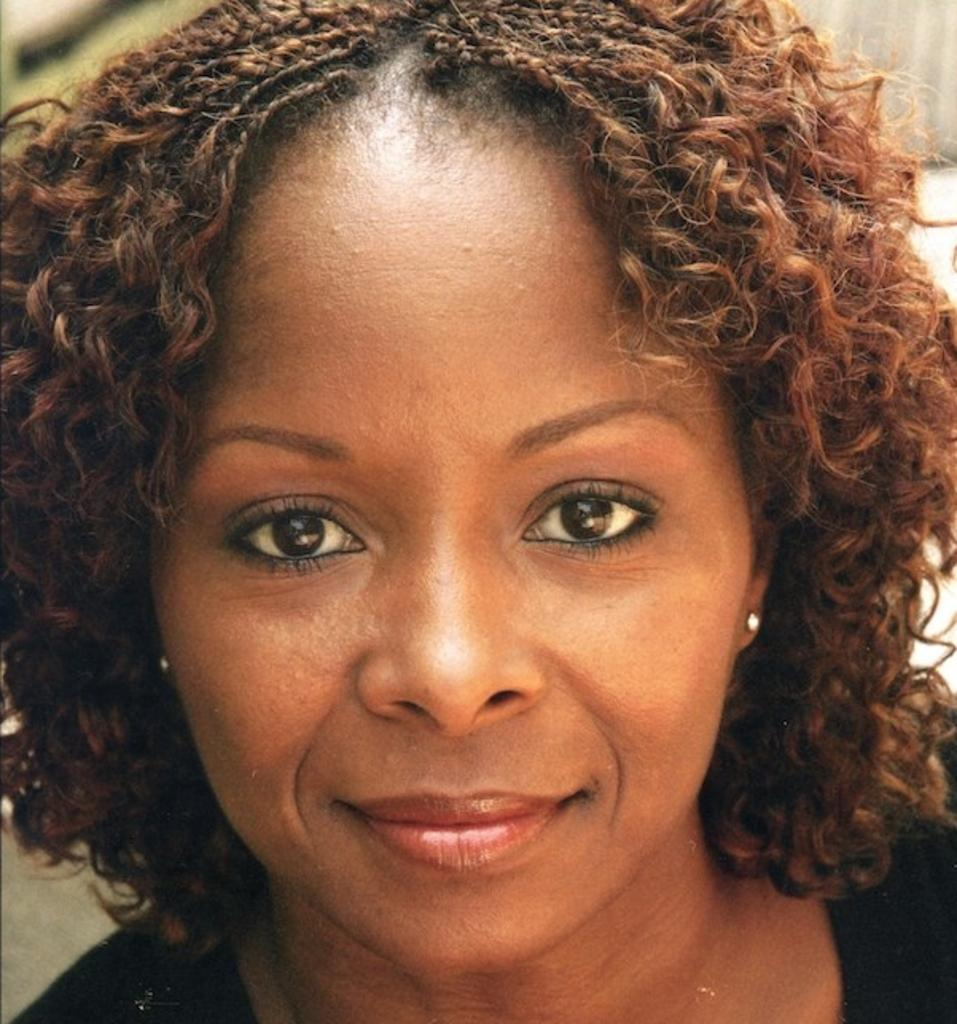Who is the main subject in the image? There is a woman in the image. Can you describe the woman's hair? The woman has curly hair. What is the woman wearing in the image? The woman is wearing a black t-shirt. What can be said about the background of the image? The background of the image is not clear. How many nails can be seen in the woman's arm in the image? There are no nails visible on the woman's arm in the image, nor is there any reference to nails in the provided facts. 